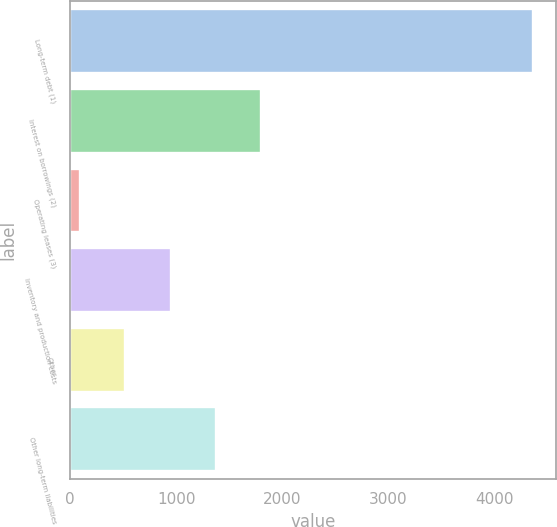Convert chart. <chart><loc_0><loc_0><loc_500><loc_500><bar_chart><fcel>Long-term debt (1)<fcel>Interest on borrowings (2)<fcel>Operating leases (3)<fcel>Inventory and production costs<fcel>Other<fcel>Other long-term liabilities<nl><fcel>4358<fcel>1800.2<fcel>95<fcel>947.6<fcel>521.3<fcel>1373.9<nl></chart> 